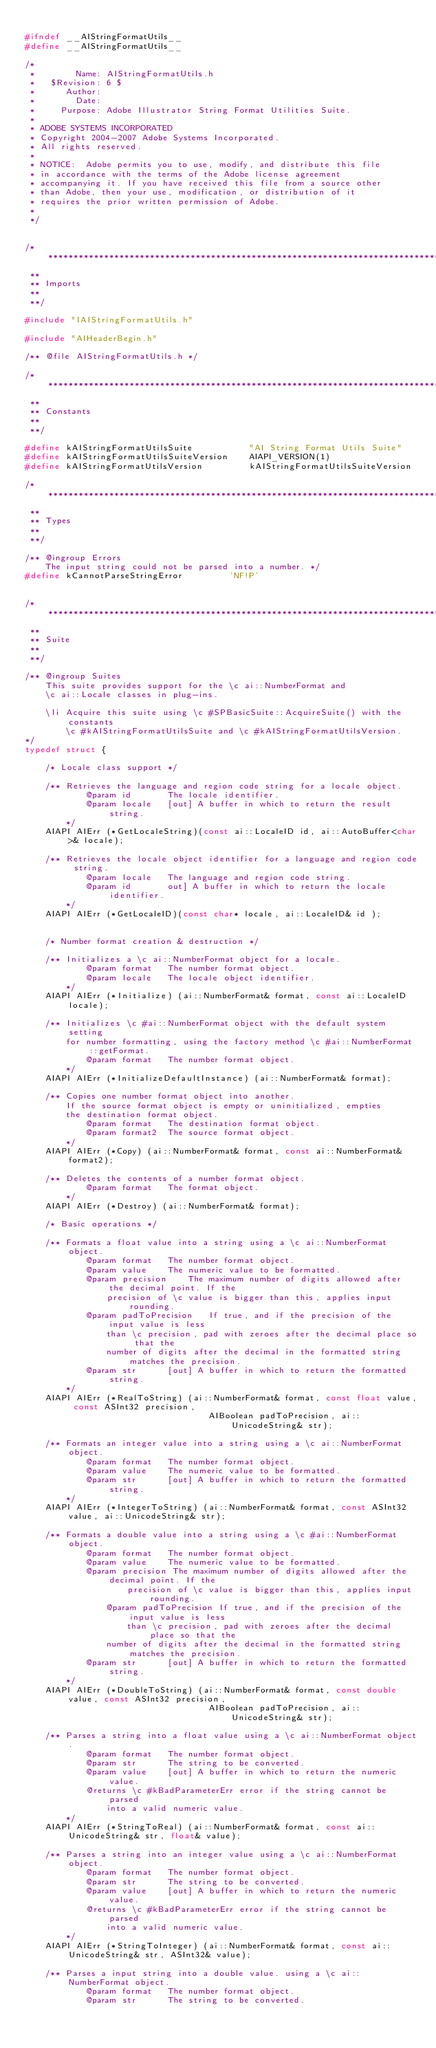Convert code to text. <code><loc_0><loc_0><loc_500><loc_500><_C_>
#ifndef __AIStringFormatUtils__
#define __AIStringFormatUtils__

/*
 *        Name:	AIStringFormatUtils.h
 *   $Revision: 6 $
 *      Author:
 *        Date:
 *     Purpose:	Adobe Illustrator String Format Utilities Suite.
 *
 * ADOBE SYSTEMS INCORPORATED
 * Copyright 2004-2007 Adobe Systems Incorporated.
 * All rights reserved.
 *
 * NOTICE:  Adobe permits you to use, modify, and distribute this file 
 * in accordance with the terms of the Adobe license agreement 
 * accompanying it. If you have received this file from a source other 
 * than Adobe, then your use, modification, or distribution of it 
 * requires the prior written permission of Adobe.
 *
 */


/*******************************************************************************
 **
 **	Imports
 **
 **/

#include "IAIStringFormatUtils.h"

#include "AIHeaderBegin.h"

/** @file AIStringFormatUtils.h */

/*******************************************************************************
 **
 ** Constants
 **
 **/

#define kAIStringFormatUtilsSuite			"AI String Format Utils Suite"
#define kAIStringFormatUtilsSuiteVersion	AIAPI_VERSION(1)
#define kAIStringFormatUtilsVersion			kAIStringFormatUtilsSuiteVersion

/*******************************************************************************
 **
 ** Types
 **
 **/

/** @ingroup Errors
	The input string could not be parsed into a number. */
#define kCannotParseStringError			'NF!P'


/*******************************************************************************
 **
 **	Suite
 **
 **/

/**	@ingroup Suites
	This suite provides support for the \c ai::NumberFormat and
	\c ai::Locale classes in plug-ins.

  	\li Acquire this suite using \c #SPBasicSuite::AcquireSuite() with the constants
		\c #kAIStringFormatUtilsSuite and \c #kAIStringFormatUtilsVersion.
*/
typedef struct {

	/* Locale class support */

	/** Retrieves the language and region code string for a locale object.
		    @param id		The locale identifier.
			@param locale	[out] A buffer in which to return the result string.
	  	*/
	AIAPI AIErr (*GetLocaleString)(const ai::LocaleID id, ai::AutoBuffer<char>& locale);

	/** Retrieves the locale object identifier for a language and region code string.
			@param locale	The language and region code string.
	    	@param id		out] A buffer in which to return the locale identifier.
 	  	*/
	AIAPI AIErr (*GetLocaleID)(const char* locale, ai::LocaleID& id );


	/* Number format creation & destruction */

	/** Initializes a \c ai::NumberFormat object for a locale.
	  		@param format	The number format object.
	   		@param locale	The locale object identifier.
     	*/
	AIAPI AIErr (*Initialize) (ai::NumberFormat& format, const ai::LocaleID locale);

	/** Initializes \c #ai::NumberFormat object with the default system setting
 		for number formatting, using the factory method \c #ai::NumberFormat::getFormat.
			@param format	The number format object.
 		*/
	AIAPI AIErr (*InitializeDefaultInstance) (ai::NumberFormat& format);

	/** Copies one number format object into another.
		If the source format object is empty or uninitialized, empties
		the destination format object.
			@param format	The destination format object.
			@param format2	The source format object.
 		*/
	AIAPI AIErr (*Copy) (ai::NumberFormat& format, const ai::NumberFormat& format2);

	/** Deletes the contents of a number format object.
	  		@param format	The format object.
   		*/
	AIAPI AIErr (*Destroy) (ai::NumberFormat& format);

	/* Basic operations */

	/** Formats a float value into a string using a \c ai::NumberFormat object.
			@param format	The number format object.
			@param value	The numeric value to be formatted.
			@param precision	The maximum number of digits allowed after the decimal point. If the
				precision of \c value is bigger than this, applies input rounding.
			@param padToPrecision	If true, and if the precision of the input value is less
				than \c precision, pad with zeroes after the decimal place so that the
				number of digits after the decimal in the formatted string matches the precision.
			@param str		[out] A buffer in which to return the formatted string.
		*/
	AIAPI AIErr (*RealToString) (ai::NumberFormat& format, const float value, const ASInt32 precision,
									AIBoolean padToPrecision, ai::UnicodeString& str);

	/** Formats an integer value into a string using a \c ai::NumberFormat object.
			@param format	The number format object.
			@param value	The numeric value to be formatted.
			@param str		[out] A buffer in which to return the formatted string.
		*/
	AIAPI AIErr (*IntegerToString) (ai::NumberFormat& format, const ASInt32 value, ai::UnicodeString& str);

	/** Formats a double value into a string using a \c #ai::NumberFormat object.
			@param format	The number format object.
			@param value	The numeric value to be formatted.
			@param precision The maximum number of digits allowed after the decimal point. If the
					precision of \c value is bigger than this, applies input rounding.
				@param padToPrecision If true, and if the precision of the input value is less
					than \c precision, pad with zeroes after the decimal place so that the
				number of digits after the decimal in the formatted string matches the precision.
			@param str		[out] A buffer in which to return the formatted string.
		*/
	AIAPI AIErr (*DoubleToString) (ai::NumberFormat& format, const double value, const ASInt32 precision,
									AIBoolean padToPrecision, ai::UnicodeString& str);

	/** Parses a string into a float value using a \c ai::NumberFormat object.
			@param format	The number format object.
			@param str		The string to be converted.
			@param value	[out] A buffer in which to return the numeric value.
			@returns \c #kBadParameterErr error if the string cannot be parsed
				into a valid numeric value.
		*/
	AIAPI AIErr (*StringToReal) (ai::NumberFormat& format, const ai::UnicodeString& str, float& value);

	/** Parses a string into an integer value using a \c ai::NumberFormat object.
			@param format	The number format object.
			@param str		The string to be converted.
			@param value	[out] A buffer in which to return the numeric value.
			@returns \c #kBadParameterErr error if the string cannot be parsed
				into a valid numeric value.
		*/
	AIAPI AIErr (*StringToInteger) (ai::NumberFormat& format, const ai::UnicodeString& str, ASInt32& value);

	/** Parses a input string into a double value. using a \c ai::NumberFormat object.
			@param format	The number format object.
			@param str		The string to be converted.</code> 